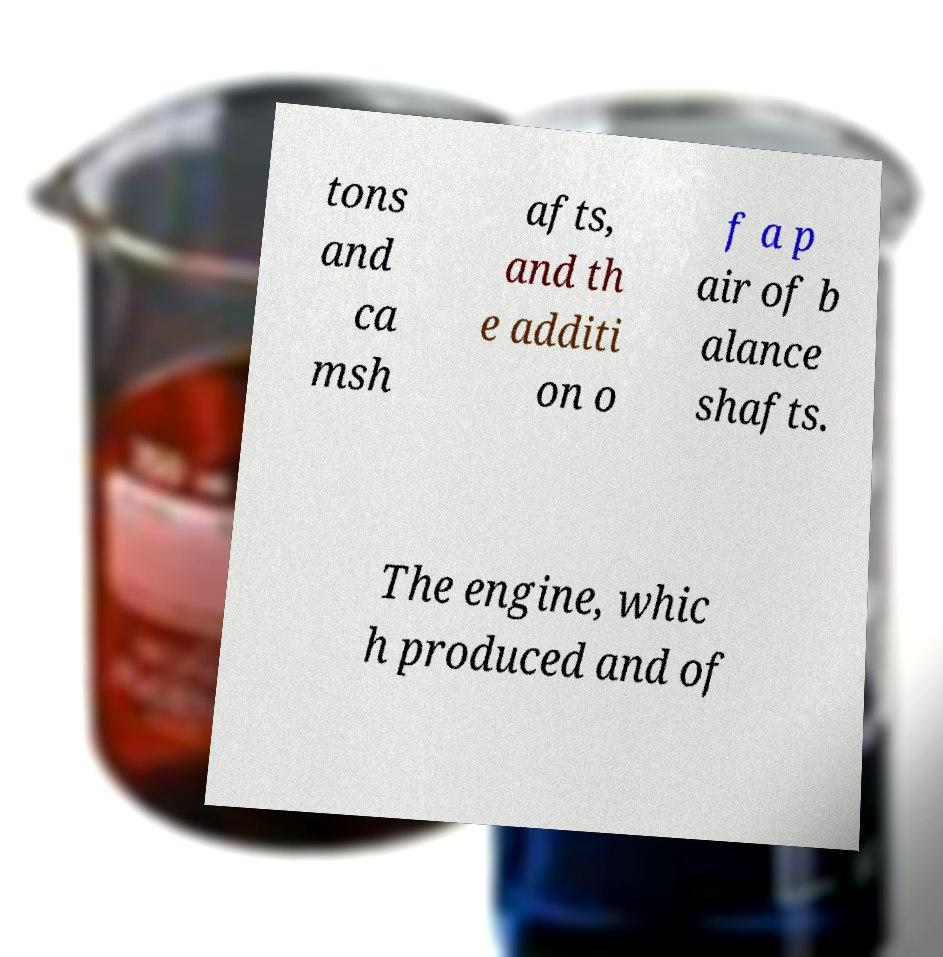Please read and relay the text visible in this image. What does it say? tons and ca msh afts, and th e additi on o f a p air of b alance shafts. The engine, whic h produced and of 